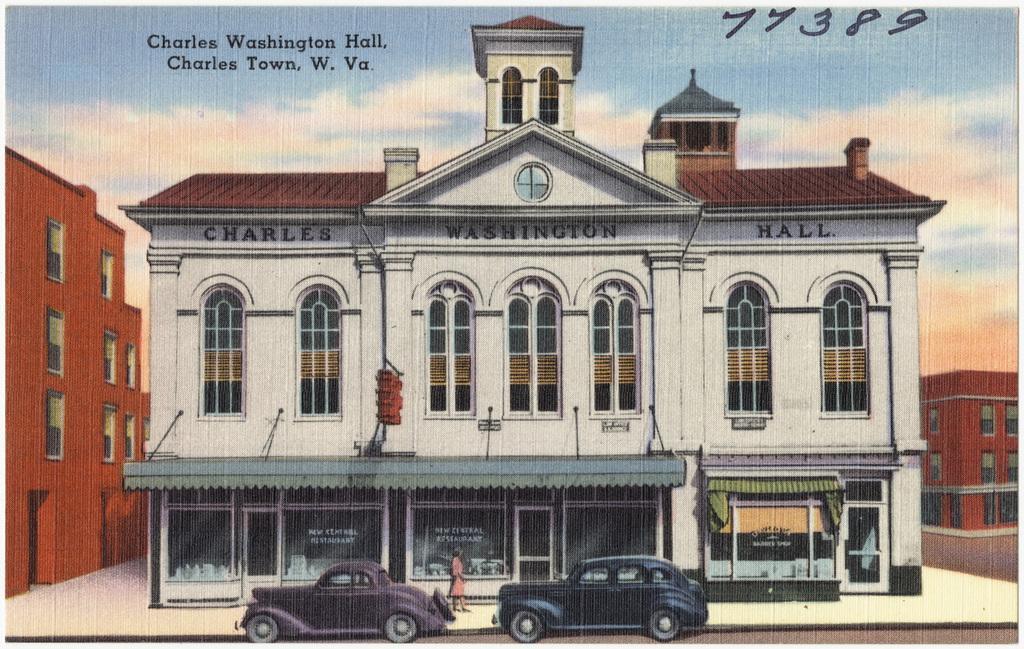Could you give a brief overview of what you see in this image? This is an animated image, in this image there are some buildings and at the bottom there are two cars and one person is walking on a footpath. On the top of the image there is sky and some text is written. 